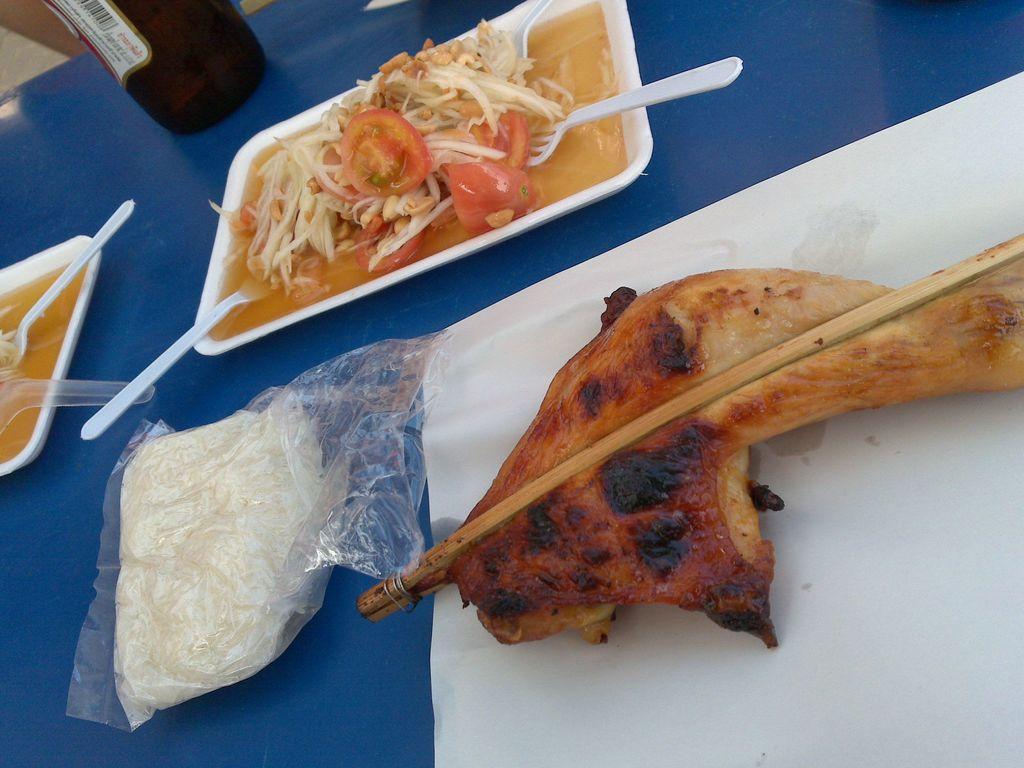Can you describe this image briefly? In the image we can see there is a table on which there are food items. In a tray there are noodles and tomato soup and on another train there is meat. 